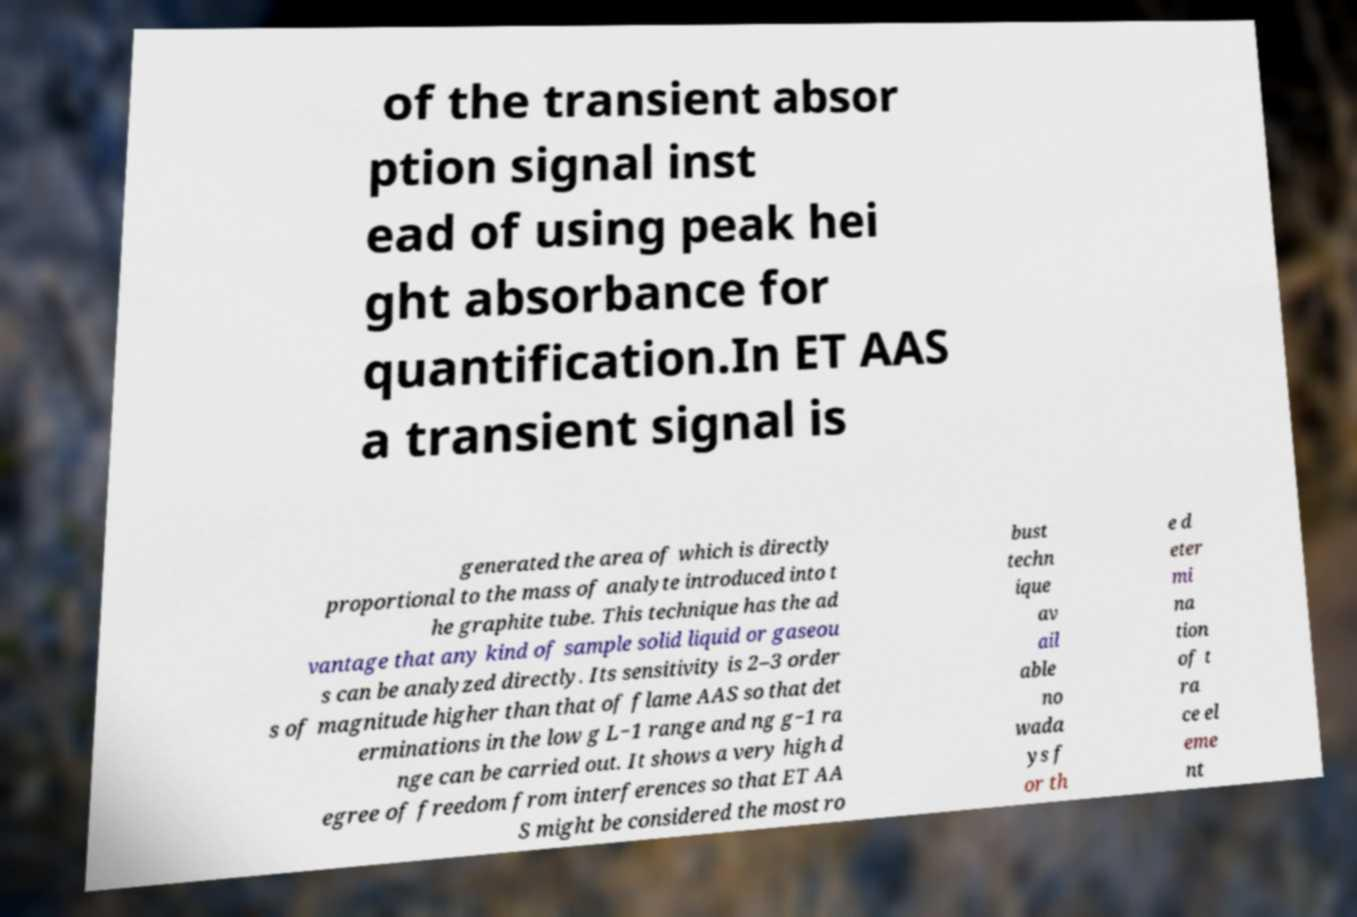Can you read and provide the text displayed in the image?This photo seems to have some interesting text. Can you extract and type it out for me? of the transient absor ption signal inst ead of using peak hei ght absorbance for quantification.In ET AAS a transient signal is generated the area of which is directly proportional to the mass of analyte introduced into t he graphite tube. This technique has the ad vantage that any kind of sample solid liquid or gaseou s can be analyzed directly. Its sensitivity is 2–3 order s of magnitude higher than that of flame AAS so that det erminations in the low g L−1 range and ng g−1 ra nge can be carried out. It shows a very high d egree of freedom from interferences so that ET AA S might be considered the most ro bust techn ique av ail able no wada ys f or th e d eter mi na tion of t ra ce el eme nt 